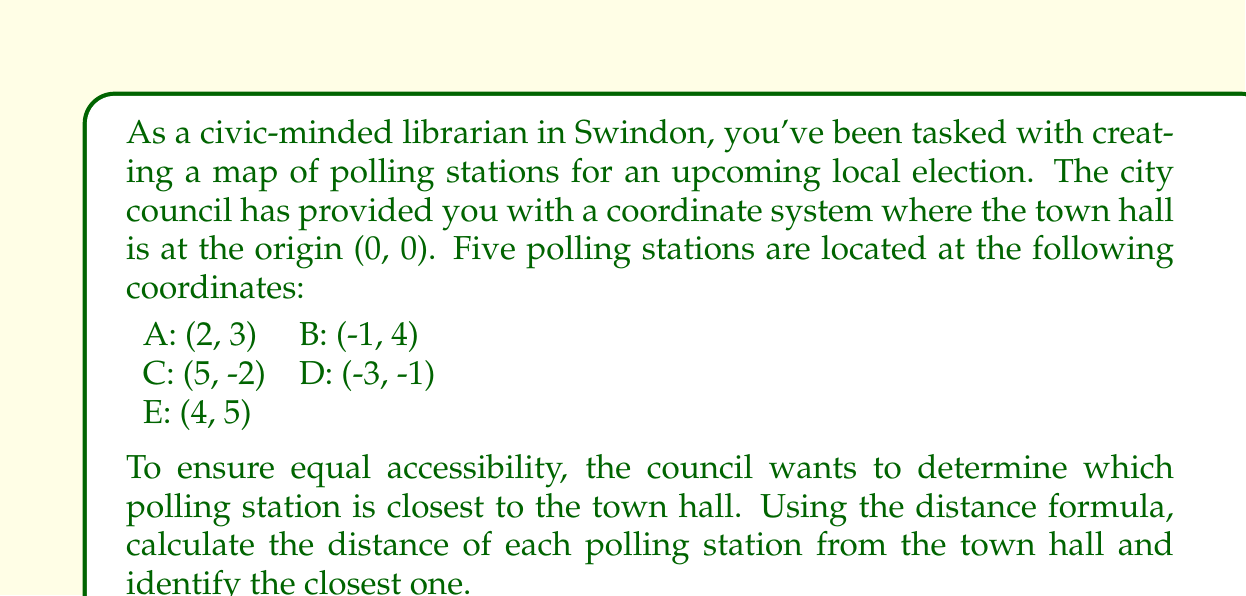What is the answer to this math problem? To solve this problem, we need to follow these steps:

1. Recall the distance formula: For two points $(x_1, y_1)$ and $(x_2, y_2)$, the distance $d$ between them is given by:

   $$d = \sqrt{(x_2 - x_1)^2 + (y_2 - y_1)^2}$$

2. In our case, $(x_1, y_1)$ is always (0, 0) as it represents the town hall. So our formula simplifies to:

   $$d = \sqrt{x^2 + y^2}$$

3. Let's calculate the distance for each polling station:

   For A (2, 3): 
   $$d_A = \sqrt{2^2 + 3^2} = \sqrt{4 + 9} = \sqrt{13} \approx 3.61$$

   For B (-1, 4):
   $$d_B = \sqrt{(-1)^2 + 4^2} = \sqrt{1 + 16} = \sqrt{17} \approx 4.12$$

   For C (5, -2):
   $$d_C = \sqrt{5^2 + (-2)^2} = \sqrt{25 + 4} = \sqrt{29} \approx 5.39$$

   For D (-3, -1):
   $$d_D = \sqrt{(-3)^2 + (-1)^2} = \sqrt{9 + 1} = \sqrt{10} \approx 3.16$$

   For E (4, 5):
   $$d_E = \sqrt{4^2 + 5^2} = \sqrt{16 + 25} = \sqrt{41} \approx 6.40$$

4. Compare the distances to find the smallest:
   $d_D < d_A < d_B < d_C < d_E$

Therefore, polling station D is closest to the town hall.
Answer: The polling station closest to the town hall is D, located at (-3, -1), with a distance of $\sqrt{10} \approx 3.16$ units from the town hall. 